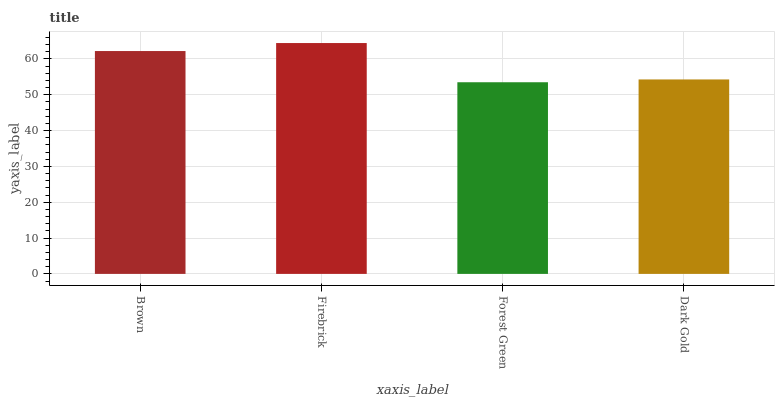Is Firebrick the minimum?
Answer yes or no. No. Is Forest Green the maximum?
Answer yes or no. No. Is Firebrick greater than Forest Green?
Answer yes or no. Yes. Is Forest Green less than Firebrick?
Answer yes or no. Yes. Is Forest Green greater than Firebrick?
Answer yes or no. No. Is Firebrick less than Forest Green?
Answer yes or no. No. Is Brown the high median?
Answer yes or no. Yes. Is Dark Gold the low median?
Answer yes or no. Yes. Is Firebrick the high median?
Answer yes or no. No. Is Firebrick the low median?
Answer yes or no. No. 